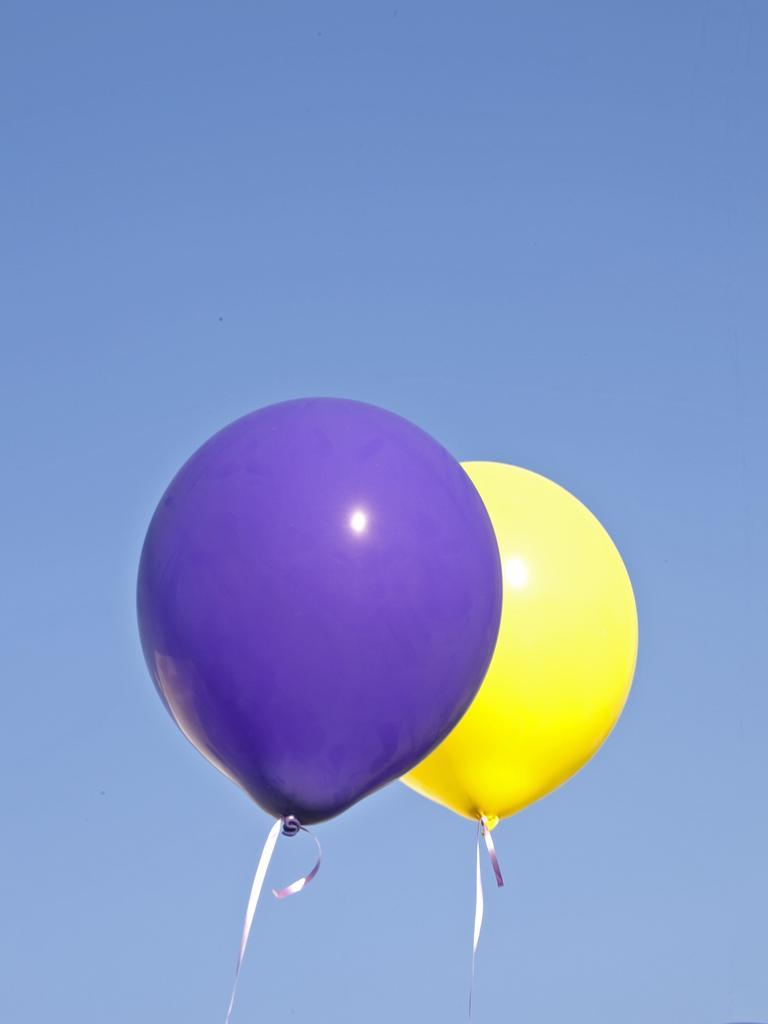Could you give a brief overview of what you see in this image? In this picture I can see 2 balloons, which are of purple and yellow color. In the background I can see the clear sky. 